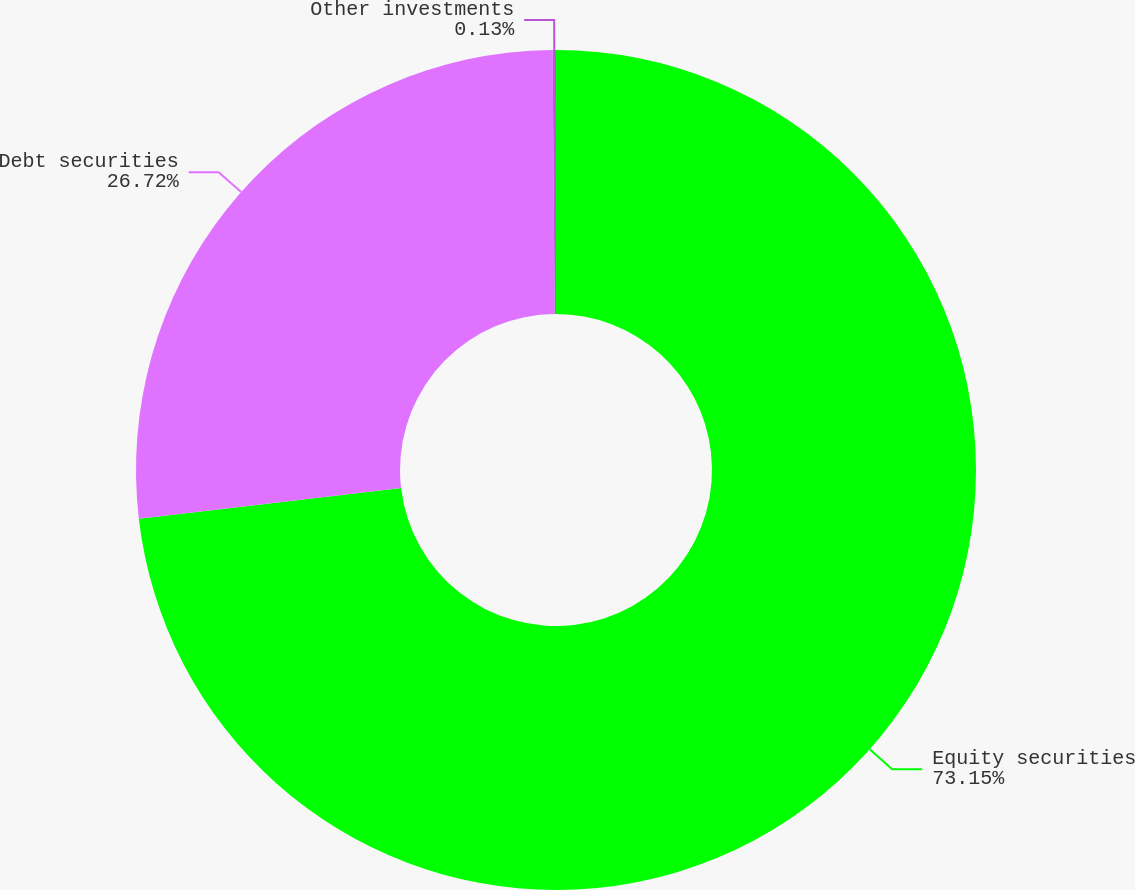<chart> <loc_0><loc_0><loc_500><loc_500><pie_chart><fcel>Equity securities<fcel>Debt securities<fcel>Other investments<nl><fcel>73.15%<fcel>26.72%<fcel>0.13%<nl></chart> 